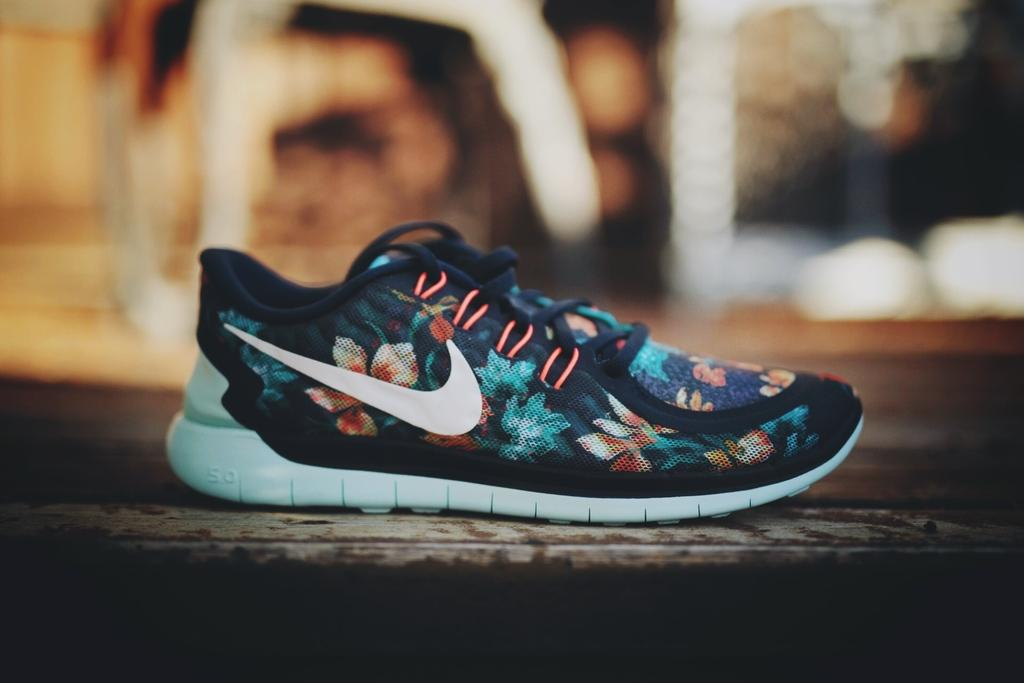What object is the main focus of the image? There is a shoe in the image. Where is the shoe located? The shoe is on a platform. What word is written on the shoe in the image? There is no word written on the shoe in the image. How many crates are visible in the image? There are no crates present in the image. 